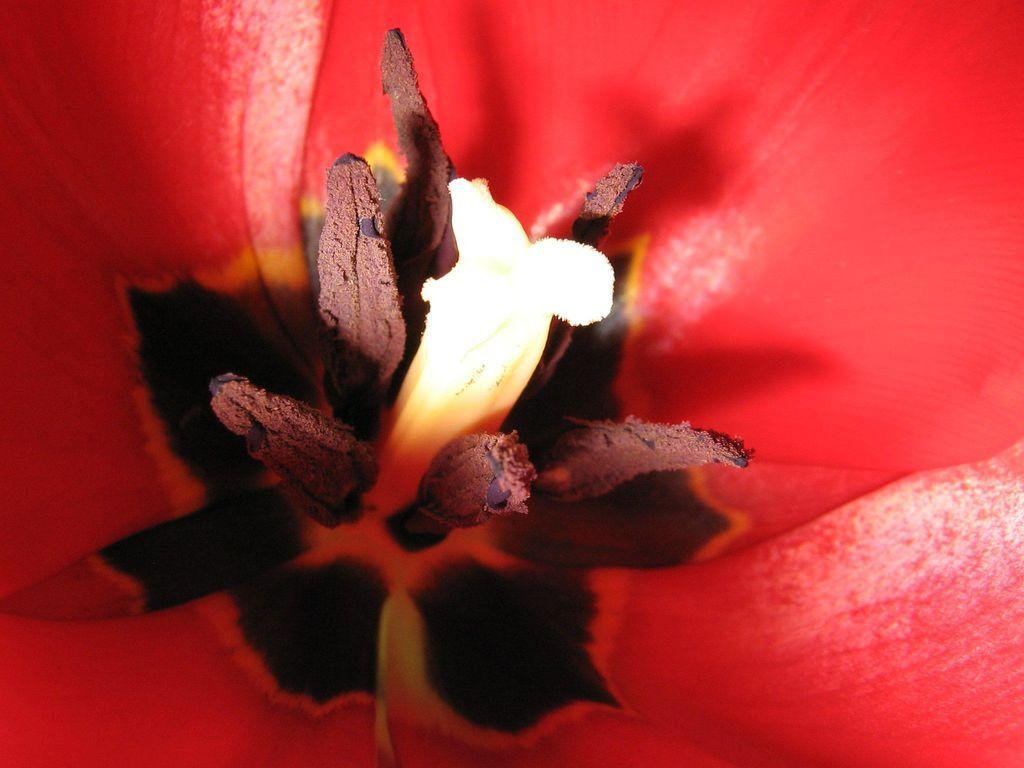What is the main subject of the image? The main subject of the image is a flower. How close is the view of the flower in the image? The image provides a closeup view of the flower. What can be seen on the flower in the image? Pollen grains are visible in the image. What type of straw is used to hold the flower in the image? There is no straw present in the image; the flower is not being held by anything. 